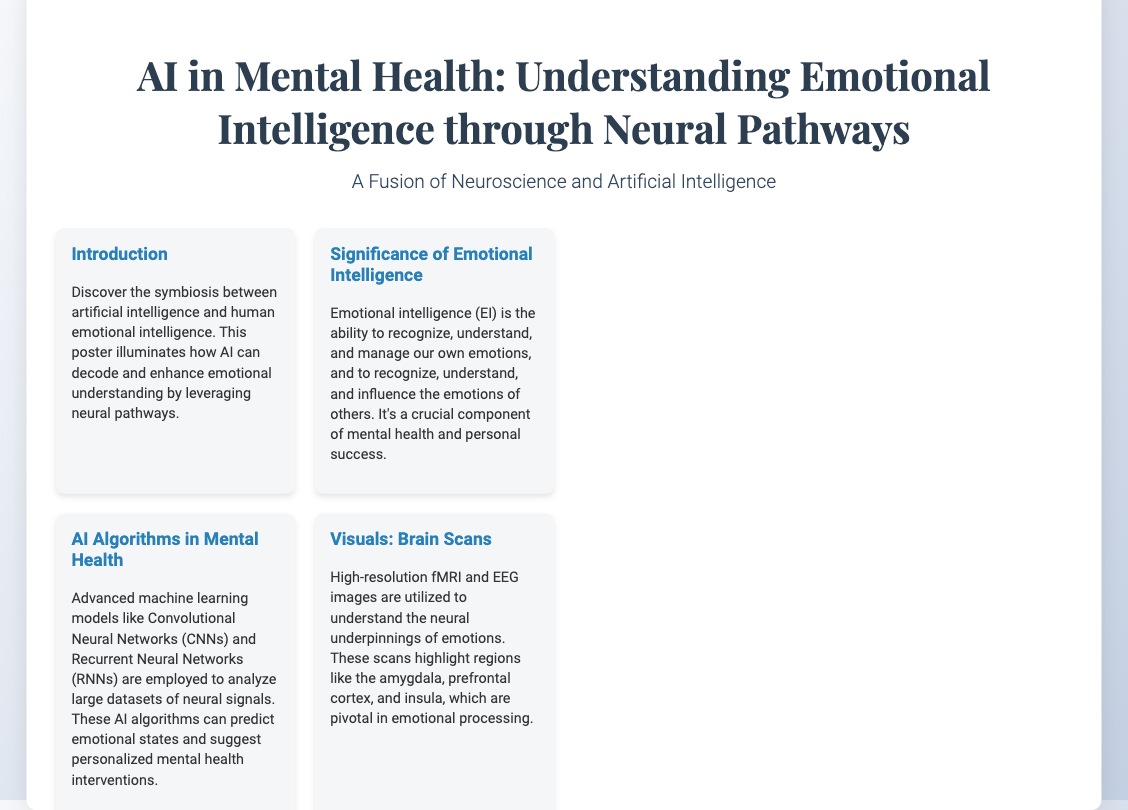What is the title of the poster? The title is prominently displayed at the top of the document.
Answer: AI in Mental Health: Understanding Emotional Intelligence through Neural Pathways What machine learning models are mentioned in the document? The document lists specific AI algorithms utilized in mental health analysis.
Answer: Convolutional Neural Networks and Recurrent Neural Networks What year is the footer copyright from? The footer provides the year related to the content shared.
Answer: 2023 What is the significant emotional intelligence component discussed? The explanation focuses on the essential quality of emotional intelligence highlighted in the document.
Answer: Recognize, understand, and manage emotions Which company is highlighted in the case study? The document specifies the organization used as an example of AI in mental health.
Answer: IBM Watson Health What types of images are utilized to understand emotions? The poster identifies specific imaging techniques used in the analysis of emotional processing.
Answer: fMRI and EEG images What tools offer real-time emotional support? The section discusses specific applications designed to assist individuals in managing their emotions.
Answer: Woebot and Wysa What is the potential future innovation in mental health care mentioned? The document hints at advancements in technology related to emotional monitoring devices.
Answer: Real-time emotional monitoring devices 